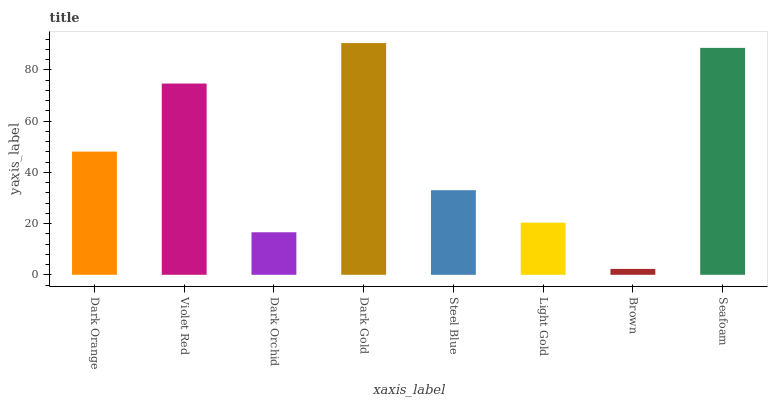Is Brown the minimum?
Answer yes or no. Yes. Is Dark Gold the maximum?
Answer yes or no. Yes. Is Violet Red the minimum?
Answer yes or no. No. Is Violet Red the maximum?
Answer yes or no. No. Is Violet Red greater than Dark Orange?
Answer yes or no. Yes. Is Dark Orange less than Violet Red?
Answer yes or no. Yes. Is Dark Orange greater than Violet Red?
Answer yes or no. No. Is Violet Red less than Dark Orange?
Answer yes or no. No. Is Dark Orange the high median?
Answer yes or no. Yes. Is Steel Blue the low median?
Answer yes or no. Yes. Is Dark Orchid the high median?
Answer yes or no. No. Is Dark Orchid the low median?
Answer yes or no. No. 